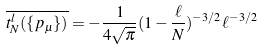Convert formula to latex. <formula><loc_0><loc_0><loc_500><loc_500>\overline { t _ { N } ^ { l } ( \{ p _ { \mu } \} ) } = - \frac { 1 } { 4 \sqrt { \pi } } ( 1 - \frac { \ell } { N } ) ^ { - 3 / 2 } \ell ^ { - 3 / 2 }</formula> 